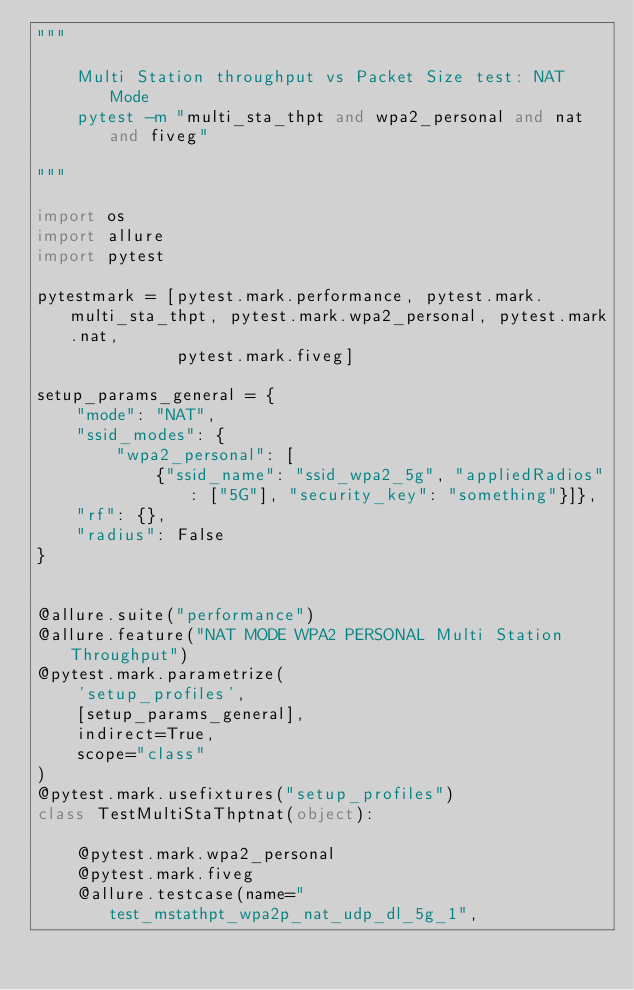Convert code to text. <code><loc_0><loc_0><loc_500><loc_500><_Python_>"""

    Multi Station throughput vs Packet Size test: NAT Mode
    pytest -m "multi_sta_thpt and wpa2_personal and nat and fiveg"

"""

import os
import allure
import pytest

pytestmark = [pytest.mark.performance, pytest.mark.multi_sta_thpt, pytest.mark.wpa2_personal, pytest.mark.nat,
              pytest.mark.fiveg]

setup_params_general = {
    "mode": "NAT",
    "ssid_modes": {
        "wpa2_personal": [
            {"ssid_name": "ssid_wpa2_5g", "appliedRadios": ["5G"], "security_key": "something"}]},
    "rf": {},
    "radius": False
}


@allure.suite("performance")
@allure.feature("NAT MODE WPA2 PERSONAL Multi Station Throughput")
@pytest.mark.parametrize(
    'setup_profiles',
    [setup_params_general],
    indirect=True,
    scope="class"
)
@pytest.mark.usefixtures("setup_profiles")
class TestMultiStaThptnat(object):

    @pytest.mark.wpa2_personal
    @pytest.mark.fiveg
    @allure.testcase(name="test_mstathpt_wpa2p_nat_udp_dl_5g_1",</code> 